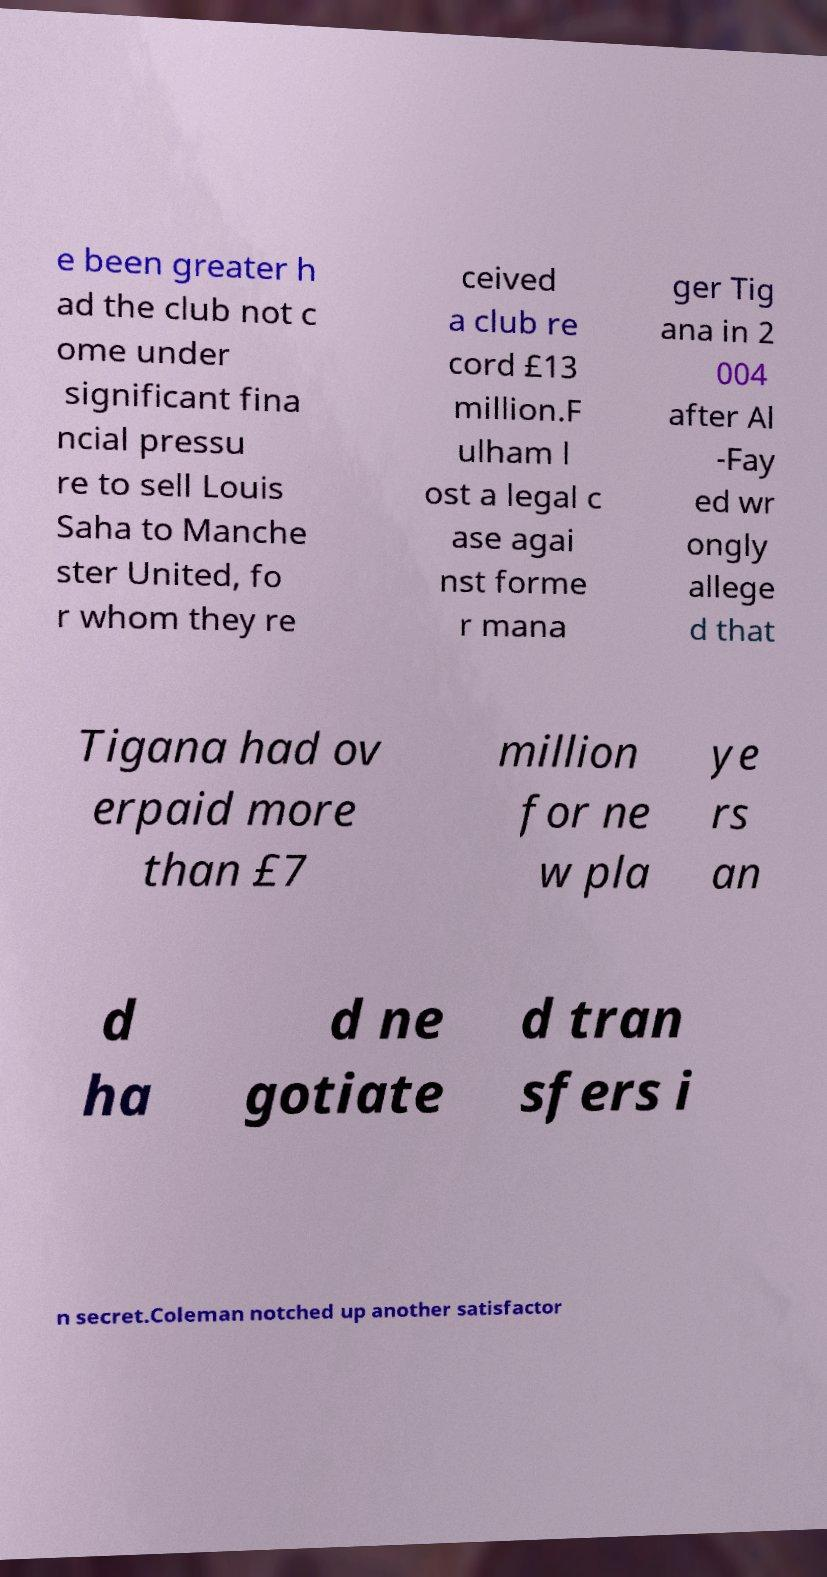Could you extract and type out the text from this image? e been greater h ad the club not c ome under significant fina ncial pressu re to sell Louis Saha to Manche ster United, fo r whom they re ceived a club re cord £13 million.F ulham l ost a legal c ase agai nst forme r mana ger Tig ana in 2 004 after Al -Fay ed wr ongly allege d that Tigana had ov erpaid more than £7 million for ne w pla ye rs an d ha d ne gotiate d tran sfers i n secret.Coleman notched up another satisfactor 